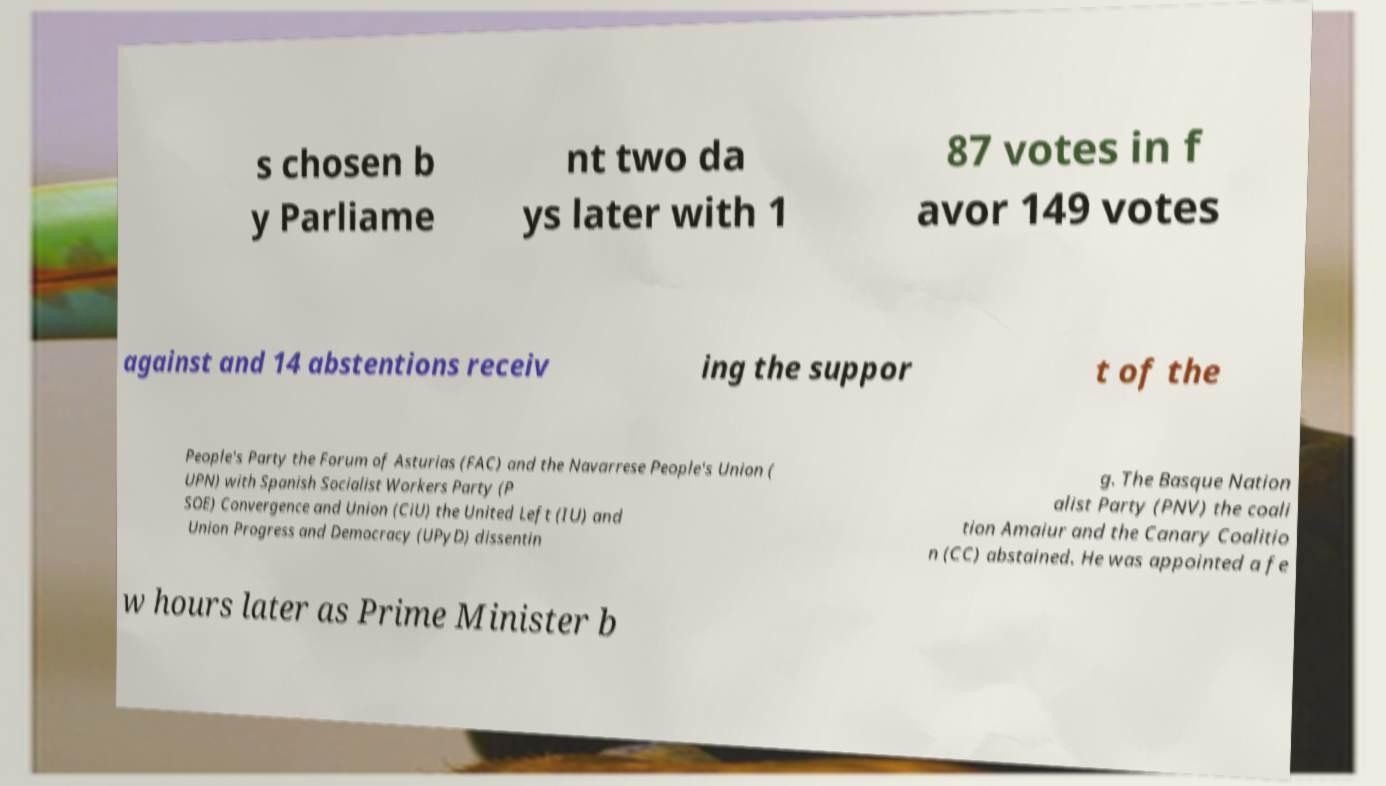Could you assist in decoding the text presented in this image and type it out clearly? s chosen b y Parliame nt two da ys later with 1 87 votes in f avor 149 votes against and 14 abstentions receiv ing the suppor t of the People's Party the Forum of Asturias (FAC) and the Navarrese People's Union ( UPN) with Spanish Socialist Workers Party (P SOE) Convergence and Union (CiU) the United Left (IU) and Union Progress and Democracy (UPyD) dissentin g. The Basque Nation alist Party (PNV) the coali tion Amaiur and the Canary Coalitio n (CC) abstained. He was appointed a fe w hours later as Prime Minister b 